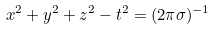<formula> <loc_0><loc_0><loc_500><loc_500>x ^ { 2 } + y ^ { 2 } + z ^ { 2 } - t ^ { 2 } = ( 2 \pi \sigma ) ^ { - 1 }</formula> 